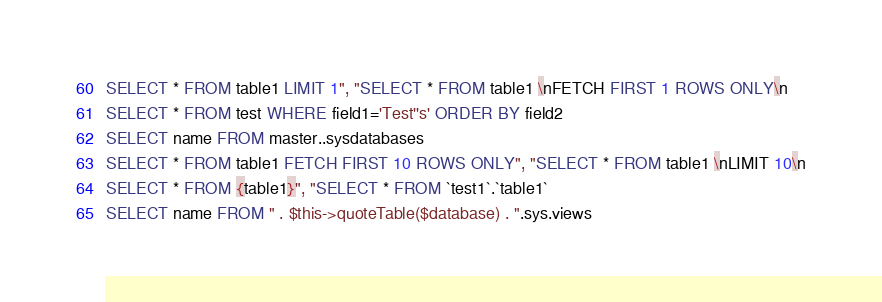<code> <loc_0><loc_0><loc_500><loc_500><_SQL_>SELECT * FROM table1 LIMIT 1", "SELECT * FROM table1 \nFETCH FIRST 1 ROWS ONLY\n
SELECT * FROM test WHERE field1='Test''s' ORDER BY field2
SELECT name FROM master..sysdatabases
SELECT * FROM table1 FETCH FIRST 10 ROWS ONLY", "SELECT * FROM table1 \nLIMIT 10\n
SELECT * FROM {table1}", "SELECT * FROM `test1`.`table1`
SELECT name FROM " . $this->quoteTable($database) . ".sys.views
</code> 